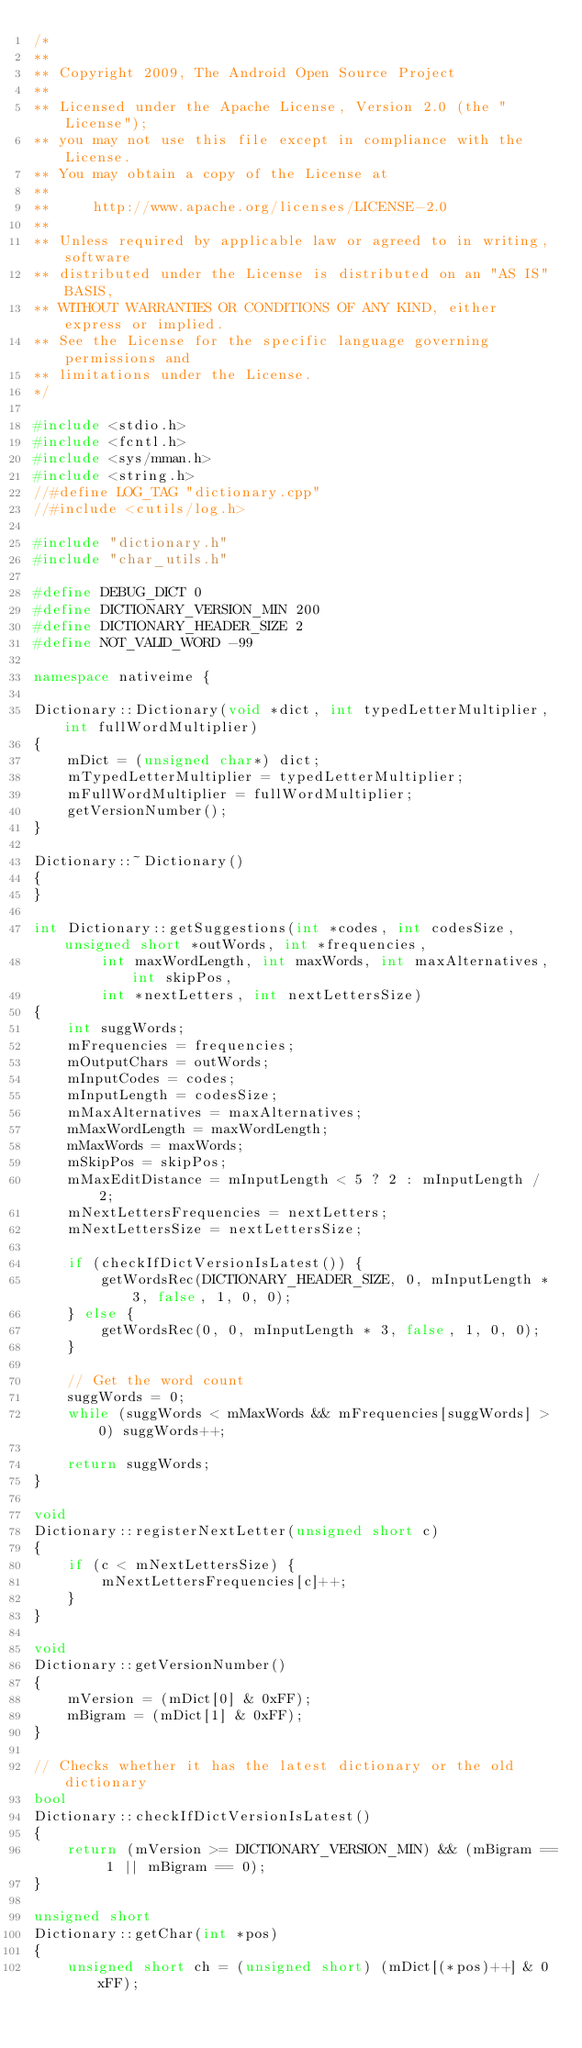<code> <loc_0><loc_0><loc_500><loc_500><_C++_>/*
**
** Copyright 2009, The Android Open Source Project
**
** Licensed under the Apache License, Version 2.0 (the "License");
** you may not use this file except in compliance with the License.
** You may obtain a copy of the License at
**
**     http://www.apache.org/licenses/LICENSE-2.0
**
** Unless required by applicable law or agreed to in writing, software
** distributed under the License is distributed on an "AS IS" BASIS,
** WITHOUT WARRANTIES OR CONDITIONS OF ANY KIND, either express or implied.
** See the License for the specific language governing permissions and
** limitations under the License.
*/

#include <stdio.h>
#include <fcntl.h>
#include <sys/mman.h>
#include <string.h>
//#define LOG_TAG "dictionary.cpp"
//#include <cutils/log.h>

#include "dictionary.h"
#include "char_utils.h"

#define DEBUG_DICT 0
#define DICTIONARY_VERSION_MIN 200
#define DICTIONARY_HEADER_SIZE 2
#define NOT_VALID_WORD -99

namespace nativeime {

Dictionary::Dictionary(void *dict, int typedLetterMultiplier, int fullWordMultiplier)
{
    mDict = (unsigned char*) dict;
    mTypedLetterMultiplier = typedLetterMultiplier;
    mFullWordMultiplier = fullWordMultiplier;
    getVersionNumber();
}

Dictionary::~Dictionary()
{
}

int Dictionary::getSuggestions(int *codes, int codesSize, unsigned short *outWords, int *frequencies,
        int maxWordLength, int maxWords, int maxAlternatives, int skipPos,
        int *nextLetters, int nextLettersSize)
{
    int suggWords;
    mFrequencies = frequencies;
    mOutputChars = outWords;
    mInputCodes = codes;
    mInputLength = codesSize;
    mMaxAlternatives = maxAlternatives;
    mMaxWordLength = maxWordLength;
    mMaxWords = maxWords;
    mSkipPos = skipPos;
    mMaxEditDistance = mInputLength < 5 ? 2 : mInputLength / 2;
    mNextLettersFrequencies = nextLetters;
    mNextLettersSize = nextLettersSize;

    if (checkIfDictVersionIsLatest()) {
        getWordsRec(DICTIONARY_HEADER_SIZE, 0, mInputLength * 3, false, 1, 0, 0);
    } else {
        getWordsRec(0, 0, mInputLength * 3, false, 1, 0, 0);
    }

    // Get the word count
    suggWords = 0;
    while (suggWords < mMaxWords && mFrequencies[suggWords] > 0) suggWords++;
    
    return suggWords;
}

void
Dictionary::registerNextLetter(unsigned short c)
{
    if (c < mNextLettersSize) {
        mNextLettersFrequencies[c]++;
    }
}

void
Dictionary::getVersionNumber()
{
    mVersion = (mDict[0] & 0xFF);
    mBigram = (mDict[1] & 0xFF);
}

// Checks whether it has the latest dictionary or the old dictionary
bool
Dictionary::checkIfDictVersionIsLatest()
{
    return (mVersion >= DICTIONARY_VERSION_MIN) && (mBigram == 1 || mBigram == 0);
}

unsigned short
Dictionary::getChar(int *pos)
{
    unsigned short ch = (unsigned short) (mDict[(*pos)++] & 0xFF);</code> 